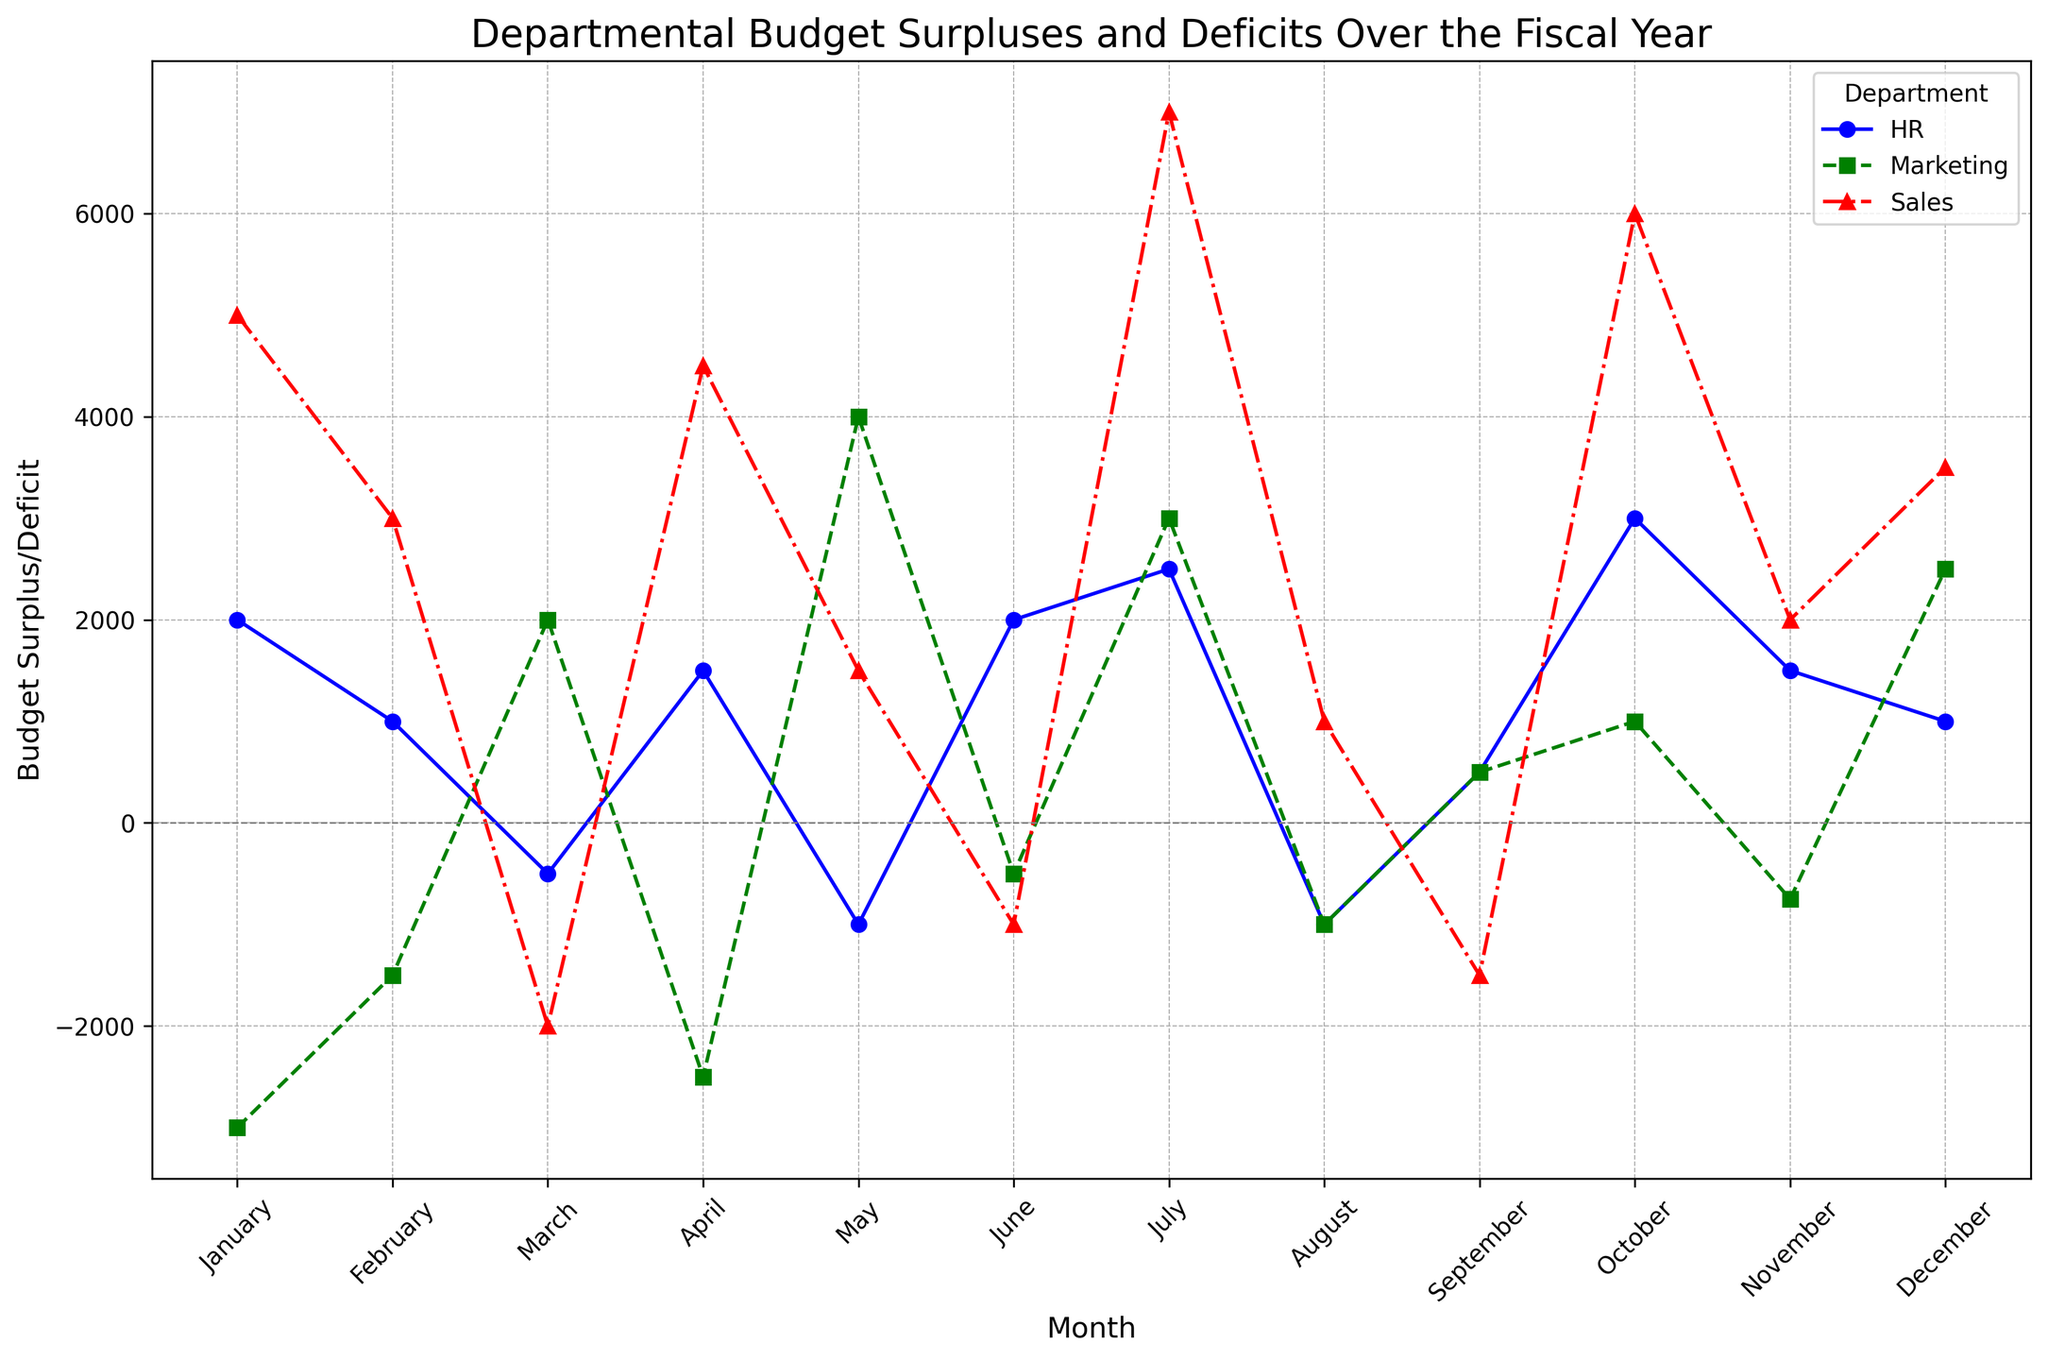Which department experienced the highest budget surplus in any month? From the figure, observe the peak points for each department over the months. The highest peak visually is the Sales department in July at 7000.
Answer: Sales in July Which department faced the most significant deficit in any month? Look for the lowest points across all months and departments. The Marketing department in January has the lowest point at -3000
Answer: Marketing in January In which month did the HR department have the highest budget surplus? Trace the HR department's trend and identify the highest point on its line. The highest point for HR is in October at 3000.
Answer: October What is the total budget surplus/deficit for the Sales department over the year? Sum up the monthly values for Sales: 5000 + 3000 - 2000 + 4500 + 1500 - 1000 + 7000 + 1000 - 1500 + 6000 + 2000 + 3500 = 24500
Answer: 24500 During which months did all departments experience a positive budget surplus? Identify the overlapping months where all three lines are above the zero line. Only in July did all lines remain above zero.
Answer: July Which department had a positive budget surplus in more months: Sales or Marketing? Count the months with positive values for each department. Sales has positive values in 9 months, while Marketing is positive in 5 months.
Answer: Sales How does the trend of the Sales department's budget compare to the Marketing department in March? Compare the positions of the Sales and Marketing lines in March. Sales is at -2000 while Marketing is at 2000, showing contrasting trends.
Answer: Sales is negative, Marketing is positive What is the range of budget surplus/deficit values for the Marketing department over the year? Identify the highest and lowest points for Marketing. High is 4000 (May) and low is -3000 (January), range is 4000 - (-3000) = 7000.
Answer: 7000 In which month did the HR department first experience a deficit? Follow the HR department's values month by month until you find the first negative value. In March, HR first sees -500.
Answer: March 